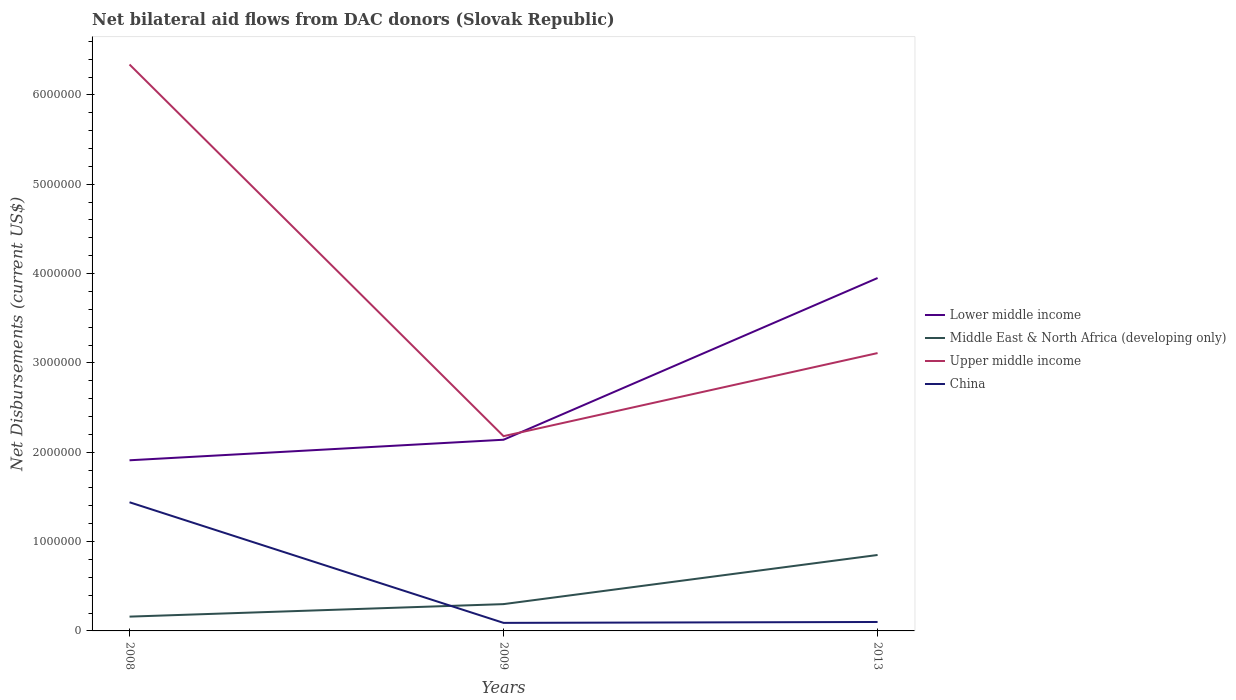How many different coloured lines are there?
Your answer should be compact. 4. Does the line corresponding to Upper middle income intersect with the line corresponding to Lower middle income?
Your answer should be very brief. Yes. Is the number of lines equal to the number of legend labels?
Your answer should be very brief. Yes. Across all years, what is the maximum net bilateral aid flows in Upper middle income?
Your response must be concise. 2.18e+06. What is the total net bilateral aid flows in Upper middle income in the graph?
Make the answer very short. 3.23e+06. What is the difference between the highest and the second highest net bilateral aid flows in China?
Keep it short and to the point. 1.35e+06. What is the difference between the highest and the lowest net bilateral aid flows in Lower middle income?
Provide a short and direct response. 1. How many lines are there?
Keep it short and to the point. 4. How many years are there in the graph?
Your answer should be compact. 3. Does the graph contain any zero values?
Your answer should be very brief. No. How are the legend labels stacked?
Provide a short and direct response. Vertical. What is the title of the graph?
Provide a short and direct response. Net bilateral aid flows from DAC donors (Slovak Republic). Does "Liechtenstein" appear as one of the legend labels in the graph?
Make the answer very short. No. What is the label or title of the X-axis?
Keep it short and to the point. Years. What is the label or title of the Y-axis?
Your response must be concise. Net Disbursements (current US$). What is the Net Disbursements (current US$) of Lower middle income in 2008?
Ensure brevity in your answer.  1.91e+06. What is the Net Disbursements (current US$) of Upper middle income in 2008?
Your response must be concise. 6.34e+06. What is the Net Disbursements (current US$) of China in 2008?
Your answer should be very brief. 1.44e+06. What is the Net Disbursements (current US$) of Lower middle income in 2009?
Your answer should be compact. 2.14e+06. What is the Net Disbursements (current US$) in Middle East & North Africa (developing only) in 2009?
Your response must be concise. 3.00e+05. What is the Net Disbursements (current US$) of Upper middle income in 2009?
Your answer should be compact. 2.18e+06. What is the Net Disbursements (current US$) in Lower middle income in 2013?
Your answer should be compact. 3.95e+06. What is the Net Disbursements (current US$) in Middle East & North Africa (developing only) in 2013?
Make the answer very short. 8.50e+05. What is the Net Disbursements (current US$) of Upper middle income in 2013?
Give a very brief answer. 3.11e+06. Across all years, what is the maximum Net Disbursements (current US$) in Lower middle income?
Keep it short and to the point. 3.95e+06. Across all years, what is the maximum Net Disbursements (current US$) of Middle East & North Africa (developing only)?
Your answer should be compact. 8.50e+05. Across all years, what is the maximum Net Disbursements (current US$) of Upper middle income?
Give a very brief answer. 6.34e+06. Across all years, what is the maximum Net Disbursements (current US$) in China?
Make the answer very short. 1.44e+06. Across all years, what is the minimum Net Disbursements (current US$) in Lower middle income?
Give a very brief answer. 1.91e+06. Across all years, what is the minimum Net Disbursements (current US$) in Middle East & North Africa (developing only)?
Your response must be concise. 1.60e+05. Across all years, what is the minimum Net Disbursements (current US$) of Upper middle income?
Ensure brevity in your answer.  2.18e+06. What is the total Net Disbursements (current US$) in Lower middle income in the graph?
Make the answer very short. 8.00e+06. What is the total Net Disbursements (current US$) of Middle East & North Africa (developing only) in the graph?
Your answer should be very brief. 1.31e+06. What is the total Net Disbursements (current US$) of Upper middle income in the graph?
Keep it short and to the point. 1.16e+07. What is the total Net Disbursements (current US$) in China in the graph?
Your answer should be compact. 1.63e+06. What is the difference between the Net Disbursements (current US$) of Middle East & North Africa (developing only) in 2008 and that in 2009?
Make the answer very short. -1.40e+05. What is the difference between the Net Disbursements (current US$) in Upper middle income in 2008 and that in 2009?
Your answer should be compact. 4.16e+06. What is the difference between the Net Disbursements (current US$) of China in 2008 and that in 2009?
Provide a short and direct response. 1.35e+06. What is the difference between the Net Disbursements (current US$) in Lower middle income in 2008 and that in 2013?
Keep it short and to the point. -2.04e+06. What is the difference between the Net Disbursements (current US$) in Middle East & North Africa (developing only) in 2008 and that in 2013?
Your answer should be very brief. -6.90e+05. What is the difference between the Net Disbursements (current US$) of Upper middle income in 2008 and that in 2013?
Provide a succinct answer. 3.23e+06. What is the difference between the Net Disbursements (current US$) of China in 2008 and that in 2013?
Make the answer very short. 1.34e+06. What is the difference between the Net Disbursements (current US$) of Lower middle income in 2009 and that in 2013?
Keep it short and to the point. -1.81e+06. What is the difference between the Net Disbursements (current US$) in Middle East & North Africa (developing only) in 2009 and that in 2013?
Offer a very short reply. -5.50e+05. What is the difference between the Net Disbursements (current US$) in Upper middle income in 2009 and that in 2013?
Provide a succinct answer. -9.30e+05. What is the difference between the Net Disbursements (current US$) in Lower middle income in 2008 and the Net Disbursements (current US$) in Middle East & North Africa (developing only) in 2009?
Keep it short and to the point. 1.61e+06. What is the difference between the Net Disbursements (current US$) of Lower middle income in 2008 and the Net Disbursements (current US$) of Upper middle income in 2009?
Your answer should be very brief. -2.70e+05. What is the difference between the Net Disbursements (current US$) in Lower middle income in 2008 and the Net Disbursements (current US$) in China in 2009?
Provide a succinct answer. 1.82e+06. What is the difference between the Net Disbursements (current US$) of Middle East & North Africa (developing only) in 2008 and the Net Disbursements (current US$) of Upper middle income in 2009?
Offer a terse response. -2.02e+06. What is the difference between the Net Disbursements (current US$) of Upper middle income in 2008 and the Net Disbursements (current US$) of China in 2009?
Offer a very short reply. 6.25e+06. What is the difference between the Net Disbursements (current US$) in Lower middle income in 2008 and the Net Disbursements (current US$) in Middle East & North Africa (developing only) in 2013?
Offer a very short reply. 1.06e+06. What is the difference between the Net Disbursements (current US$) in Lower middle income in 2008 and the Net Disbursements (current US$) in Upper middle income in 2013?
Give a very brief answer. -1.20e+06. What is the difference between the Net Disbursements (current US$) of Lower middle income in 2008 and the Net Disbursements (current US$) of China in 2013?
Provide a succinct answer. 1.81e+06. What is the difference between the Net Disbursements (current US$) of Middle East & North Africa (developing only) in 2008 and the Net Disbursements (current US$) of Upper middle income in 2013?
Provide a short and direct response. -2.95e+06. What is the difference between the Net Disbursements (current US$) of Upper middle income in 2008 and the Net Disbursements (current US$) of China in 2013?
Offer a very short reply. 6.24e+06. What is the difference between the Net Disbursements (current US$) in Lower middle income in 2009 and the Net Disbursements (current US$) in Middle East & North Africa (developing only) in 2013?
Provide a short and direct response. 1.29e+06. What is the difference between the Net Disbursements (current US$) of Lower middle income in 2009 and the Net Disbursements (current US$) of Upper middle income in 2013?
Ensure brevity in your answer.  -9.70e+05. What is the difference between the Net Disbursements (current US$) in Lower middle income in 2009 and the Net Disbursements (current US$) in China in 2013?
Provide a succinct answer. 2.04e+06. What is the difference between the Net Disbursements (current US$) of Middle East & North Africa (developing only) in 2009 and the Net Disbursements (current US$) of Upper middle income in 2013?
Ensure brevity in your answer.  -2.81e+06. What is the difference between the Net Disbursements (current US$) in Upper middle income in 2009 and the Net Disbursements (current US$) in China in 2013?
Keep it short and to the point. 2.08e+06. What is the average Net Disbursements (current US$) in Lower middle income per year?
Your answer should be very brief. 2.67e+06. What is the average Net Disbursements (current US$) of Middle East & North Africa (developing only) per year?
Give a very brief answer. 4.37e+05. What is the average Net Disbursements (current US$) in Upper middle income per year?
Offer a terse response. 3.88e+06. What is the average Net Disbursements (current US$) of China per year?
Make the answer very short. 5.43e+05. In the year 2008, what is the difference between the Net Disbursements (current US$) of Lower middle income and Net Disbursements (current US$) of Middle East & North Africa (developing only)?
Your answer should be compact. 1.75e+06. In the year 2008, what is the difference between the Net Disbursements (current US$) in Lower middle income and Net Disbursements (current US$) in Upper middle income?
Provide a succinct answer. -4.43e+06. In the year 2008, what is the difference between the Net Disbursements (current US$) in Middle East & North Africa (developing only) and Net Disbursements (current US$) in Upper middle income?
Give a very brief answer. -6.18e+06. In the year 2008, what is the difference between the Net Disbursements (current US$) of Middle East & North Africa (developing only) and Net Disbursements (current US$) of China?
Offer a very short reply. -1.28e+06. In the year 2008, what is the difference between the Net Disbursements (current US$) in Upper middle income and Net Disbursements (current US$) in China?
Provide a short and direct response. 4.90e+06. In the year 2009, what is the difference between the Net Disbursements (current US$) of Lower middle income and Net Disbursements (current US$) of Middle East & North Africa (developing only)?
Offer a terse response. 1.84e+06. In the year 2009, what is the difference between the Net Disbursements (current US$) of Lower middle income and Net Disbursements (current US$) of Upper middle income?
Provide a short and direct response. -4.00e+04. In the year 2009, what is the difference between the Net Disbursements (current US$) of Lower middle income and Net Disbursements (current US$) of China?
Offer a very short reply. 2.05e+06. In the year 2009, what is the difference between the Net Disbursements (current US$) in Middle East & North Africa (developing only) and Net Disbursements (current US$) in Upper middle income?
Offer a very short reply. -1.88e+06. In the year 2009, what is the difference between the Net Disbursements (current US$) of Middle East & North Africa (developing only) and Net Disbursements (current US$) of China?
Offer a very short reply. 2.10e+05. In the year 2009, what is the difference between the Net Disbursements (current US$) of Upper middle income and Net Disbursements (current US$) of China?
Ensure brevity in your answer.  2.09e+06. In the year 2013, what is the difference between the Net Disbursements (current US$) in Lower middle income and Net Disbursements (current US$) in Middle East & North Africa (developing only)?
Offer a terse response. 3.10e+06. In the year 2013, what is the difference between the Net Disbursements (current US$) of Lower middle income and Net Disbursements (current US$) of Upper middle income?
Keep it short and to the point. 8.40e+05. In the year 2013, what is the difference between the Net Disbursements (current US$) of Lower middle income and Net Disbursements (current US$) of China?
Provide a succinct answer. 3.85e+06. In the year 2013, what is the difference between the Net Disbursements (current US$) of Middle East & North Africa (developing only) and Net Disbursements (current US$) of Upper middle income?
Provide a short and direct response. -2.26e+06. In the year 2013, what is the difference between the Net Disbursements (current US$) of Middle East & North Africa (developing only) and Net Disbursements (current US$) of China?
Give a very brief answer. 7.50e+05. In the year 2013, what is the difference between the Net Disbursements (current US$) of Upper middle income and Net Disbursements (current US$) of China?
Your answer should be compact. 3.01e+06. What is the ratio of the Net Disbursements (current US$) in Lower middle income in 2008 to that in 2009?
Your answer should be very brief. 0.89. What is the ratio of the Net Disbursements (current US$) of Middle East & North Africa (developing only) in 2008 to that in 2009?
Give a very brief answer. 0.53. What is the ratio of the Net Disbursements (current US$) of Upper middle income in 2008 to that in 2009?
Your answer should be compact. 2.91. What is the ratio of the Net Disbursements (current US$) in China in 2008 to that in 2009?
Ensure brevity in your answer.  16. What is the ratio of the Net Disbursements (current US$) in Lower middle income in 2008 to that in 2013?
Keep it short and to the point. 0.48. What is the ratio of the Net Disbursements (current US$) in Middle East & North Africa (developing only) in 2008 to that in 2013?
Provide a short and direct response. 0.19. What is the ratio of the Net Disbursements (current US$) of Upper middle income in 2008 to that in 2013?
Make the answer very short. 2.04. What is the ratio of the Net Disbursements (current US$) in Lower middle income in 2009 to that in 2013?
Ensure brevity in your answer.  0.54. What is the ratio of the Net Disbursements (current US$) of Middle East & North Africa (developing only) in 2009 to that in 2013?
Keep it short and to the point. 0.35. What is the ratio of the Net Disbursements (current US$) in Upper middle income in 2009 to that in 2013?
Your response must be concise. 0.7. What is the ratio of the Net Disbursements (current US$) of China in 2009 to that in 2013?
Provide a short and direct response. 0.9. What is the difference between the highest and the second highest Net Disbursements (current US$) of Lower middle income?
Keep it short and to the point. 1.81e+06. What is the difference between the highest and the second highest Net Disbursements (current US$) in Upper middle income?
Provide a succinct answer. 3.23e+06. What is the difference between the highest and the second highest Net Disbursements (current US$) in China?
Give a very brief answer. 1.34e+06. What is the difference between the highest and the lowest Net Disbursements (current US$) of Lower middle income?
Make the answer very short. 2.04e+06. What is the difference between the highest and the lowest Net Disbursements (current US$) in Middle East & North Africa (developing only)?
Your answer should be very brief. 6.90e+05. What is the difference between the highest and the lowest Net Disbursements (current US$) of Upper middle income?
Your answer should be compact. 4.16e+06. What is the difference between the highest and the lowest Net Disbursements (current US$) of China?
Keep it short and to the point. 1.35e+06. 